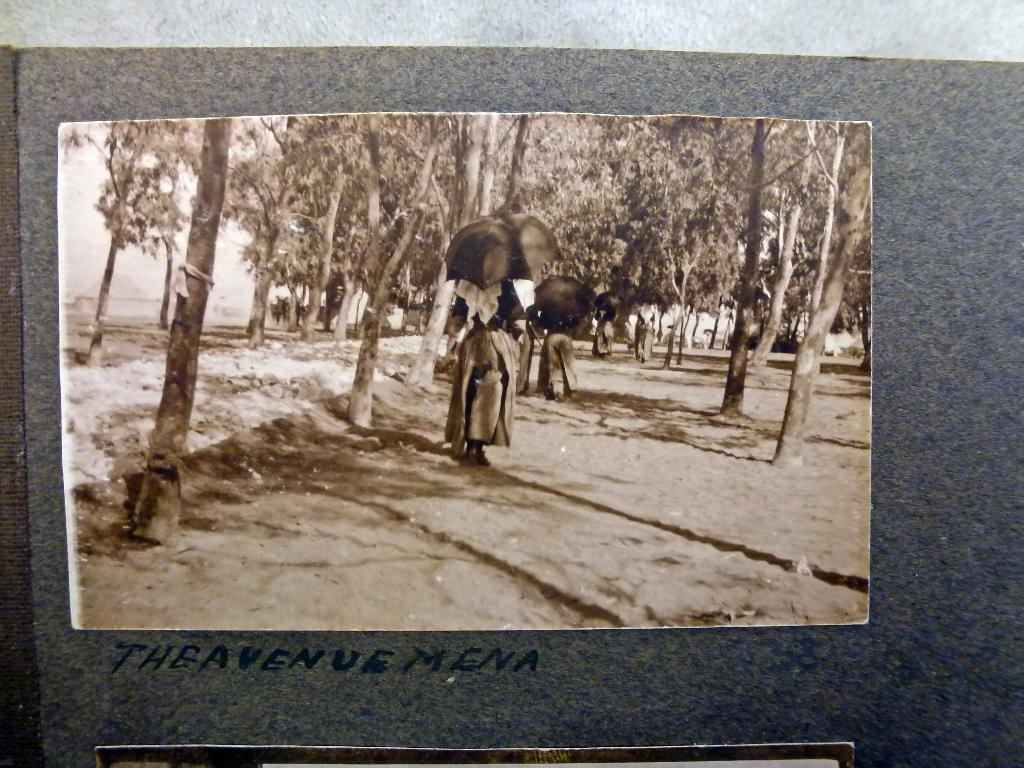What is located at the front of the image? There is a tree in the front of the image. What are the persons in the image doing? The persons are walking in the center of the image. What do the persons have with them while walking? The persons are holding an umbrella. What else can be seen in the image besides the tree and the persons? There are trees visible in the image. Where is the cushion located in the image? There is no cushion present in the image. What activity are the boys participating in the image? There is no mention of boys in the image, and no specific activity is depicted. 